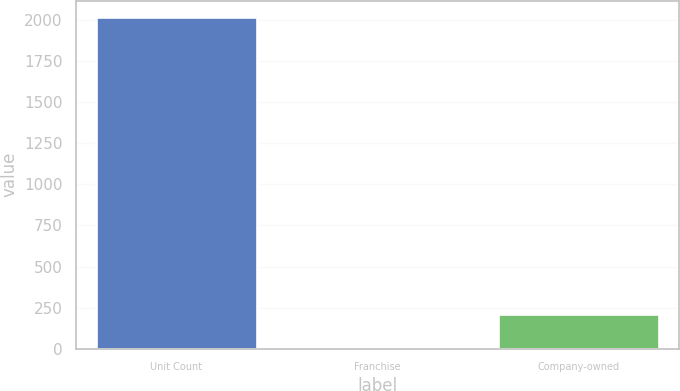<chart> <loc_0><loc_0><loc_500><loc_500><bar_chart><fcel>Unit Count<fcel>Franchise<fcel>Company-owned<nl><fcel>2017<fcel>8<fcel>208.9<nl></chart> 